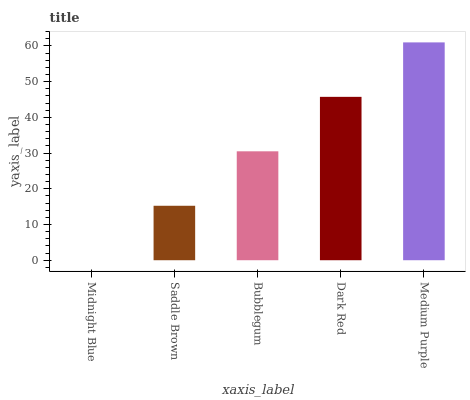Is Saddle Brown the minimum?
Answer yes or no. No. Is Saddle Brown the maximum?
Answer yes or no. No. Is Saddle Brown greater than Midnight Blue?
Answer yes or no. Yes. Is Midnight Blue less than Saddle Brown?
Answer yes or no. Yes. Is Midnight Blue greater than Saddle Brown?
Answer yes or no. No. Is Saddle Brown less than Midnight Blue?
Answer yes or no. No. Is Bubblegum the high median?
Answer yes or no. Yes. Is Bubblegum the low median?
Answer yes or no. Yes. Is Dark Red the high median?
Answer yes or no. No. Is Midnight Blue the low median?
Answer yes or no. No. 